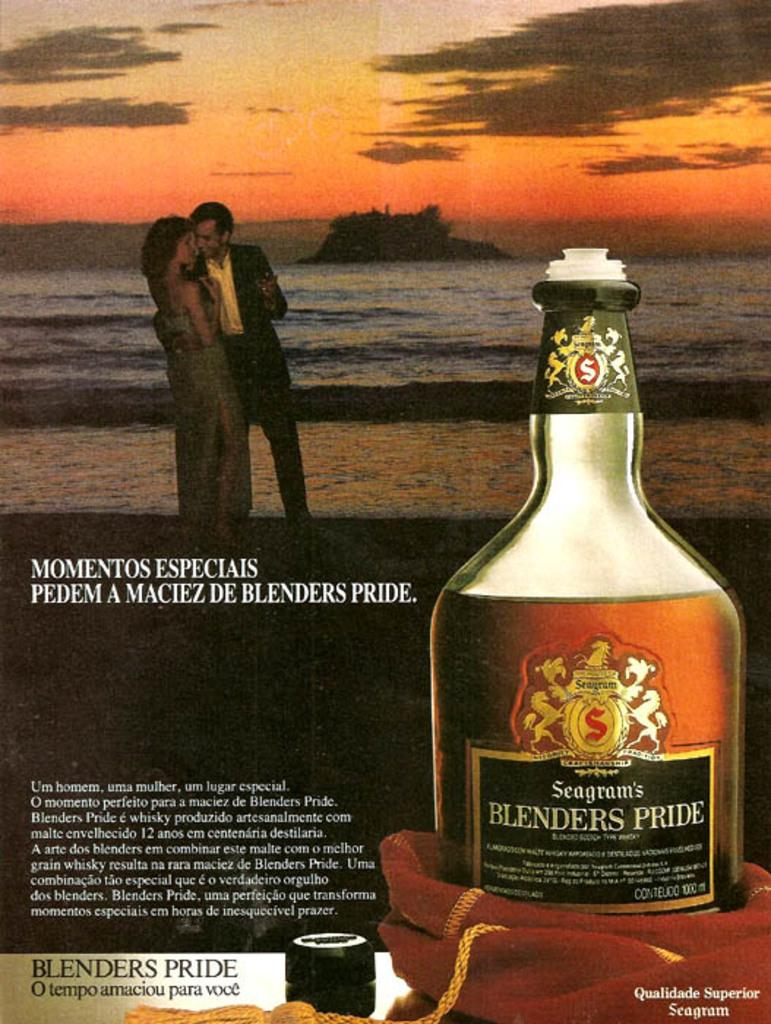What type of visual is the image? The image is a poster. What is shown on the poster? There are persons and water depicted on the poster. Are there any objects shown on the poster? Yes, there is a bottle depicted on the poster. How many apples are being carried by the beast in the image? There is no beast or apples present in the image. What type of flock is visible in the image? There is no flock visible in the image. 